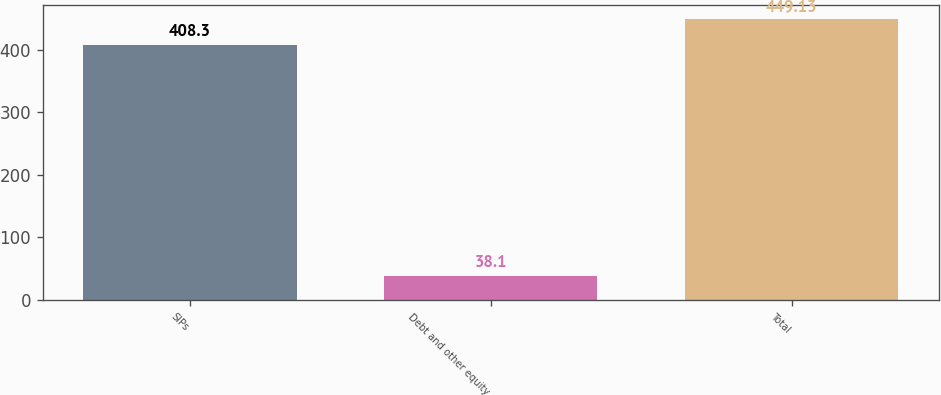Convert chart. <chart><loc_0><loc_0><loc_500><loc_500><bar_chart><fcel>SIPs<fcel>Debt and other equity<fcel>Total<nl><fcel>408.3<fcel>38.1<fcel>449.13<nl></chart> 